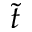<formula> <loc_0><loc_0><loc_500><loc_500>\tilde { t }</formula> 